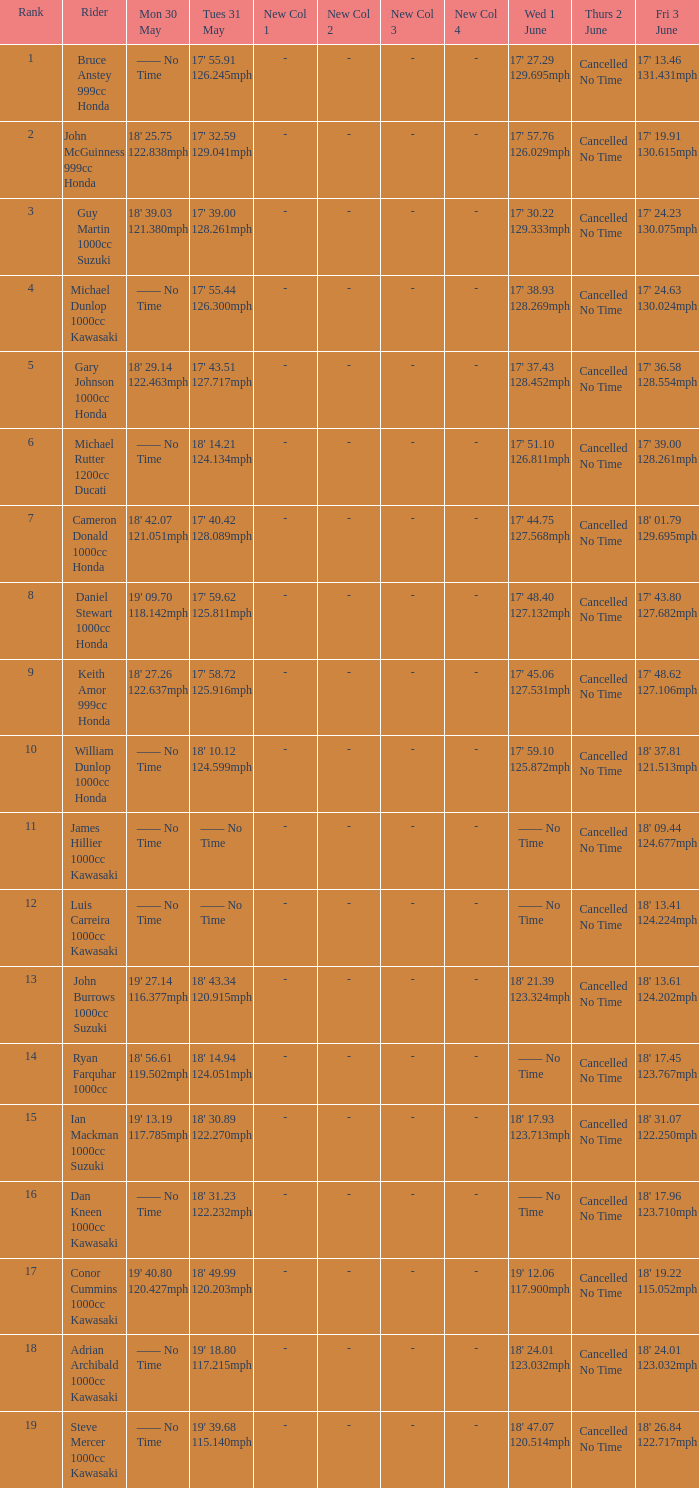What is the Fri 3 June time for the rider whose Tues 31 May time was 19' 18.80 117.215mph? 18' 24.01 123.032mph. Could you parse the entire table? {'header': ['Rank', 'Rider', 'Mon 30 May', 'Tues 31 May', 'New Col 1', 'New Col 2', 'New Col 3', 'New Col 4', 'Wed 1 June', 'Thurs 2 June', 'Fri 3 June'], 'rows': [['1', 'Bruce Anstey 999cc Honda', '—— No Time', "17' 55.91 126.245mph", '-', '-', '-', '-', "17' 27.29 129.695mph", 'Cancelled No Time', "17' 13.46 131.431mph"], ['2', 'John McGuinness 999cc Honda', "18' 25.75 122.838mph", "17' 32.59 129.041mph", '-', '-', '-', '-', "17' 57.76 126.029mph", 'Cancelled No Time', "17' 19.91 130.615mph"], ['3', 'Guy Martin 1000cc Suzuki', "18' 39.03 121.380mph", "17' 39.00 128.261mph", '-', '-', '-', '-', "17' 30.22 129.333mph", 'Cancelled No Time', "17' 24.23 130.075mph"], ['4', 'Michael Dunlop 1000cc Kawasaki', '—— No Time', "17' 55.44 126.300mph", '-', '-', '-', '-', "17' 38.93 128.269mph", 'Cancelled No Time', "17' 24.63 130.024mph"], ['5', 'Gary Johnson 1000cc Honda', "18' 29.14 122.463mph", "17' 43.51 127.717mph", '-', '-', '-', '-', "17' 37.43 128.452mph", 'Cancelled No Time', "17' 36.58 128.554mph"], ['6', 'Michael Rutter 1200cc Ducati', '—— No Time', "18' 14.21 124.134mph", '-', '-', '-', '-', "17' 51.10 126.811mph", 'Cancelled No Time', "17' 39.00 128.261mph"], ['7', 'Cameron Donald 1000cc Honda', "18' 42.07 121.051mph", "17' 40.42 128.089mph", '-', '-', '-', '-', "17' 44.75 127.568mph", 'Cancelled No Time', "18' 01.79 129.695mph"], ['8', 'Daniel Stewart 1000cc Honda', "19' 09.70 118.142mph", "17' 59.62 125.811mph", '-', '-', '-', '-', "17' 48.40 127.132mph", 'Cancelled No Time', "17' 43.80 127.682mph"], ['9', 'Keith Amor 999cc Honda', "18' 27.26 122.637mph", "17' 58.72 125.916mph", '-', '-', '-', '-', "17' 45.06 127.531mph", 'Cancelled No Time', "17' 48.62 127.106mph"], ['10', 'William Dunlop 1000cc Honda', '—— No Time', "18' 10.12 124.599mph", '-', '-', '-', '-', "17' 59.10 125.872mph", 'Cancelled No Time', "18' 37.81 121.513mph"], ['11', 'James Hillier 1000cc Kawasaki', '—— No Time', '—— No Time', '-', '-', '-', '-', '—— No Time', 'Cancelled No Time', "18' 09.44 124.677mph"], ['12', 'Luis Carreira 1000cc Kawasaki', '—— No Time', '—— No Time', '-', '-', '-', '-', '—— No Time', 'Cancelled No Time', "18' 13.41 124.224mph"], ['13', 'John Burrows 1000cc Suzuki', "19' 27.14 116.377mph", "18' 43.34 120.915mph", '-', '-', '-', '-', "18' 21.39 123.324mph", 'Cancelled No Time', "18' 13.61 124.202mph"], ['14', 'Ryan Farquhar 1000cc', "18' 56.61 119.502mph", "18' 14.94 124.051mph", '-', '-', '-', '-', '—— No Time', 'Cancelled No Time', "18' 17.45 123.767mph"], ['15', 'Ian Mackman 1000cc Suzuki', "19' 13.19 117.785mph", "18' 30.89 122.270mph", '-', '-', '-', '-', "18' 17.93 123.713mph", 'Cancelled No Time', "18' 31.07 122.250mph"], ['16', 'Dan Kneen 1000cc Kawasaki', '—— No Time', "18' 31.23 122.232mph", '-', '-', '-', '-', '—— No Time', 'Cancelled No Time', "18' 17.96 123.710mph"], ['17', 'Conor Cummins 1000cc Kawasaki', "19' 40.80 120.427mph", "18' 49.99 120.203mph", '-', '-', '-', '-', "19' 12.06 117.900mph", 'Cancelled No Time', "18' 19.22 115.052mph"], ['18', 'Adrian Archibald 1000cc Kawasaki', '—— No Time', "19' 18.80 117.215mph", '-', '-', '-', '-', "18' 24.01 123.032mph", 'Cancelled No Time', "18' 24.01 123.032mph"], ['19', 'Steve Mercer 1000cc Kawasaki', '—— No Time', "19' 39.68 115.140mph", '-', '-', '-', '-', "18' 47.07 120.514mph", 'Cancelled No Time', "18' 26.84 122.717mph"]]} 